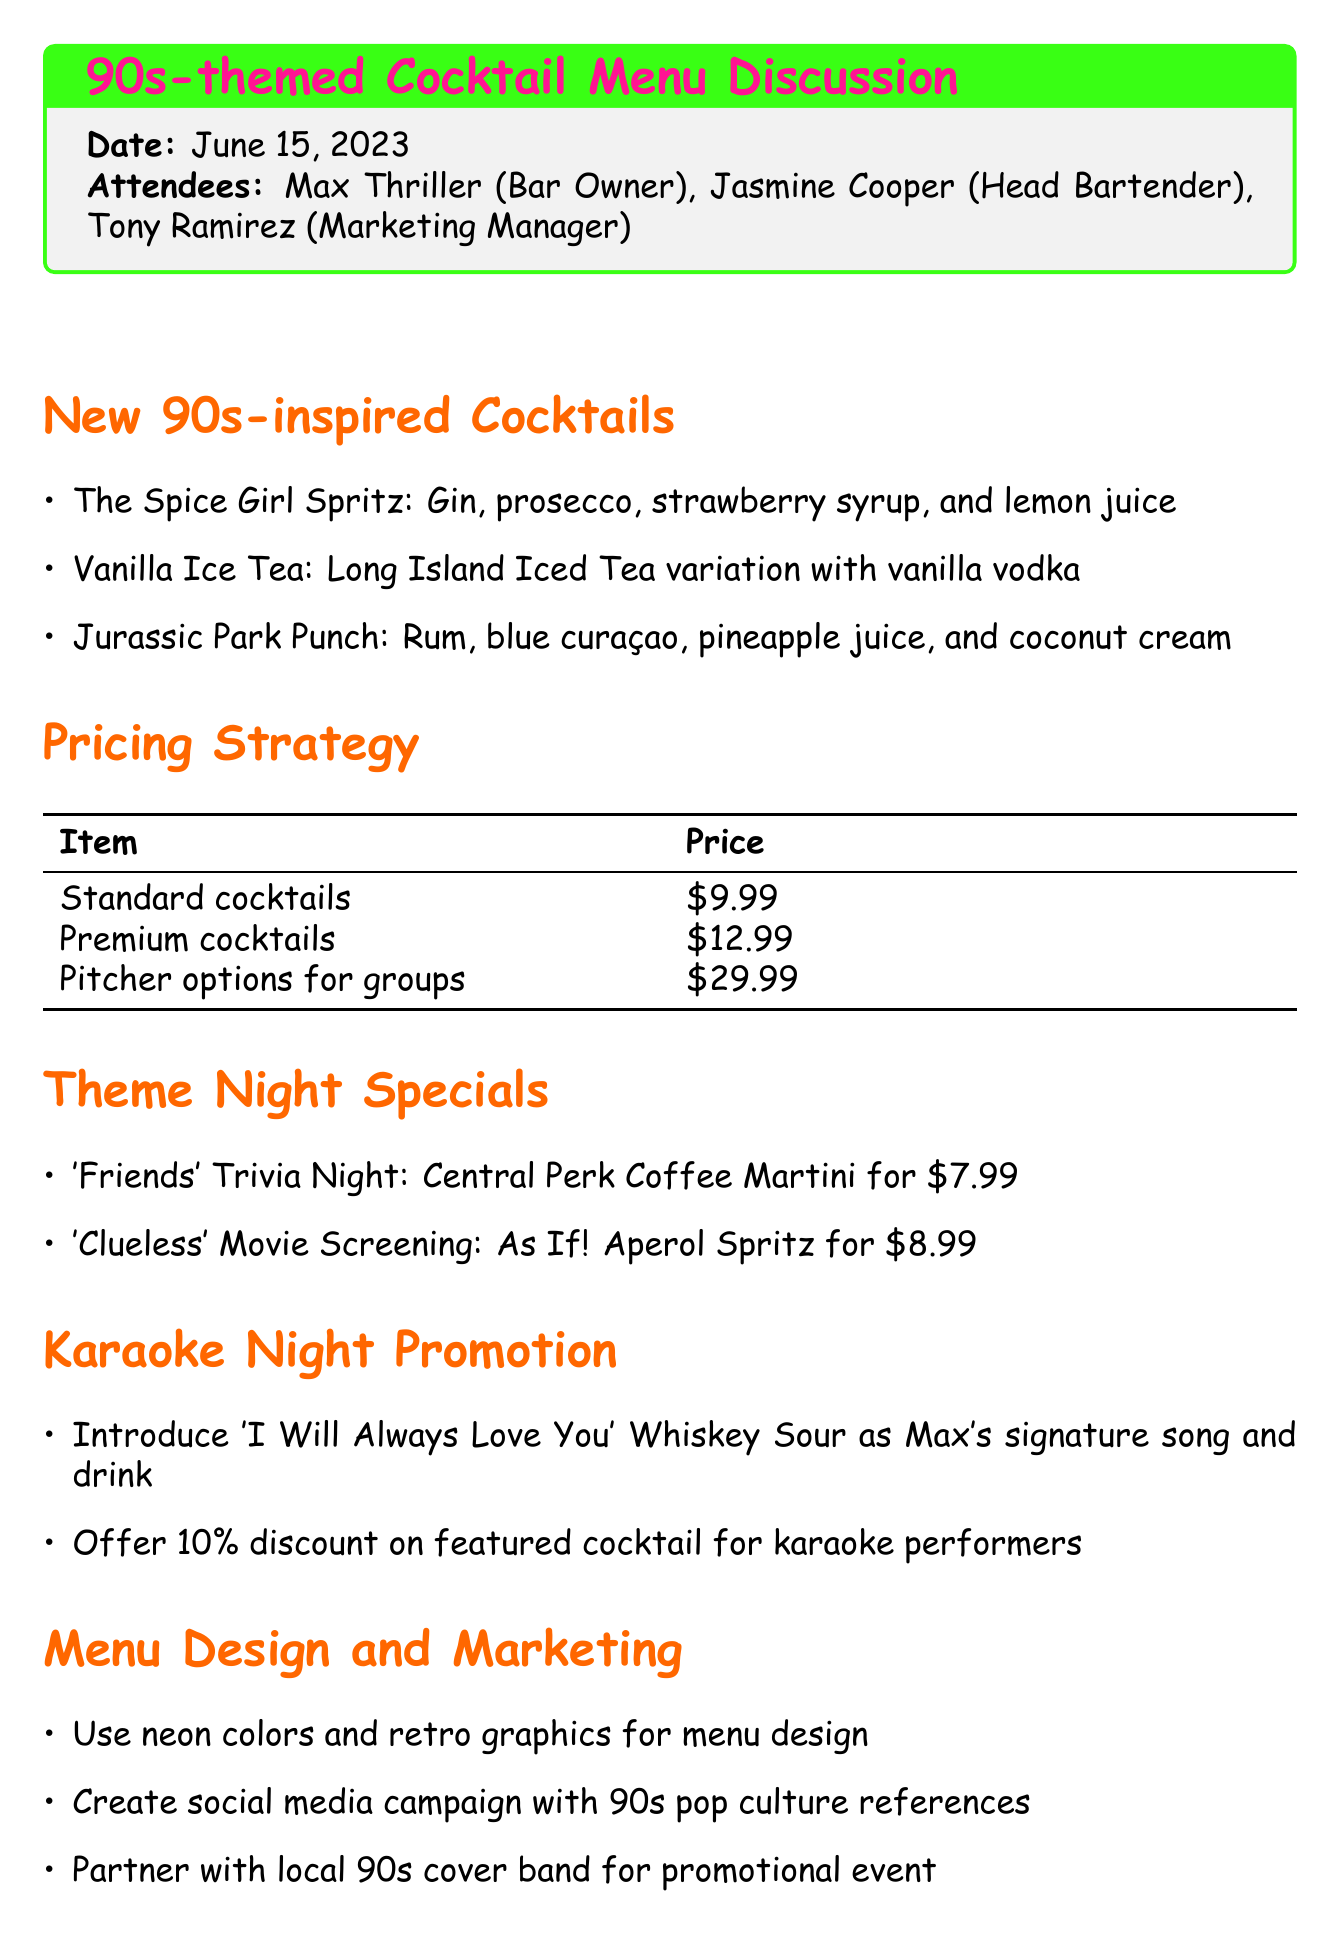What is the title of the meeting? The title of the meeting is stated in the document, which is "90s-themed Cocktail Menu Discussion."
Answer: 90s-themed Cocktail Menu Discussion When was the meeting held? The date of the meeting is specified in the document, which is June 15, 2023.
Answer: June 15, 2023 Who is the marketing manager present in the meeting? The document lists attendees, including Tony Ramirez, who holds the role of Marketing Manager.
Answer: Tony Ramirez What is the price of premium cocktails? The pricing strategy section details that premium cocktails are priced at $12.99.
Answer: $12.99 What cocktail is introduced as Max's signature drink? The document mentions that 'I Will Always Love You' Whiskey Sour is introduced as Max's signature drink and song.
Answer: 'I Will Always Love You' Whiskey Sour What is one of the theme night specials? The document provides examples of theme night specials, including 'Friends' Trivia Night.
Answer: 'Friends' Trivia Night How much is the discount for karaoke performers on featured cocktails? The document states that there is a 10% discount on featured cocktails for karaoke performers.
Answer: 10% Who is responsible for finalizing recipes and conducting taste tests? The action items section specifies that Jasmine will finalize recipes and conduct taste tests.
Answer: Jasmine What design elements will be used for the menu? The menu design and marketing section specifies the use of neon colors and retro graphics for the menu design.
Answer: Neon colors and retro graphics 